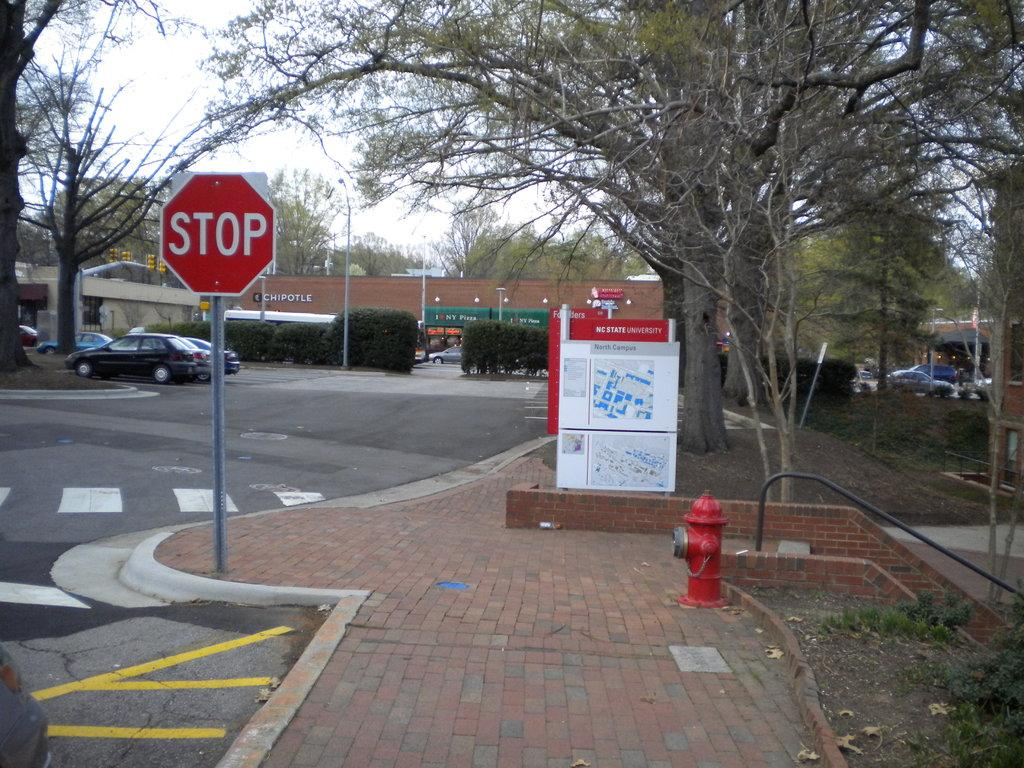<image>
Offer a succinct explanation of the picture presented. A red sign says Stop and is by a red fire hydrant. 